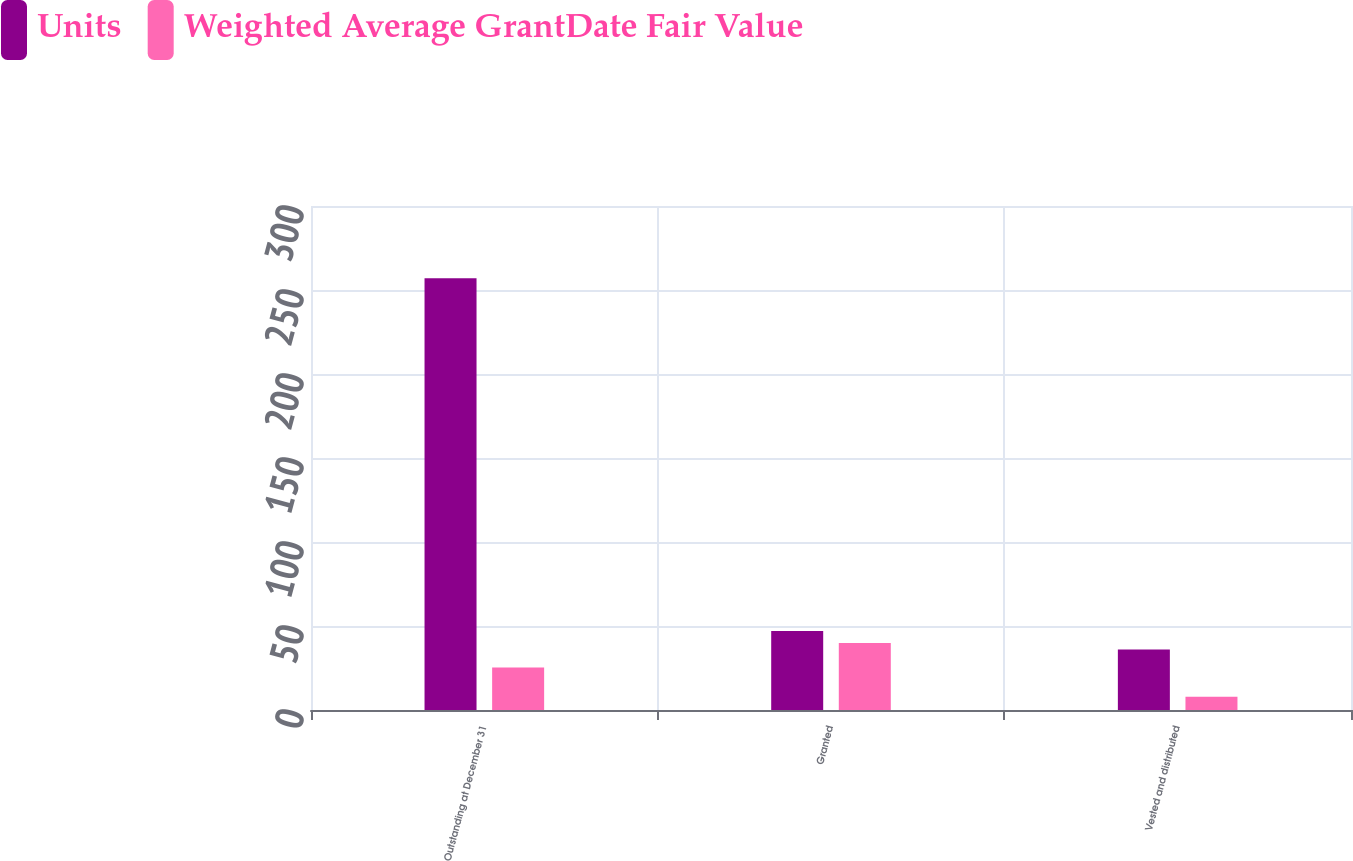<chart> <loc_0><loc_0><loc_500><loc_500><stacked_bar_chart><ecel><fcel>Outstanding at December 31<fcel>Granted<fcel>Vested and distributed<nl><fcel>Units<fcel>257<fcel>47<fcel>36<nl><fcel>Weighted Average GrantDate Fair Value<fcel>25.31<fcel>39.86<fcel>7.96<nl></chart> 